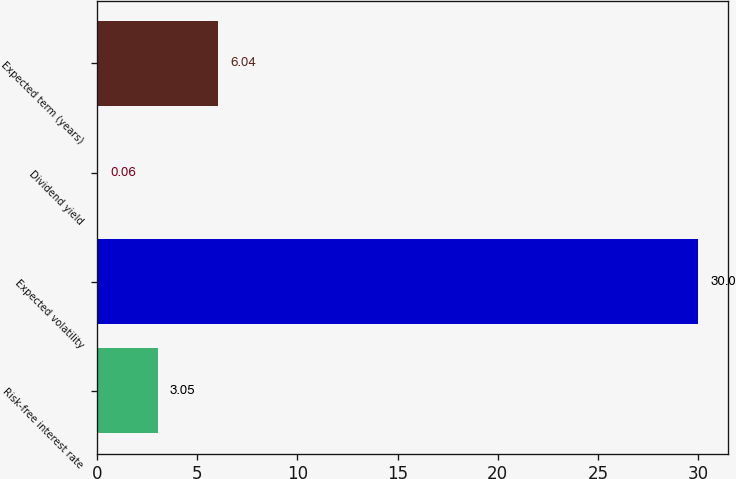Convert chart to OTSL. <chart><loc_0><loc_0><loc_500><loc_500><bar_chart><fcel>Risk-free interest rate<fcel>Expected volatility<fcel>Dividend yield<fcel>Expected term (years)<nl><fcel>3.05<fcel>30<fcel>0.06<fcel>6.04<nl></chart> 